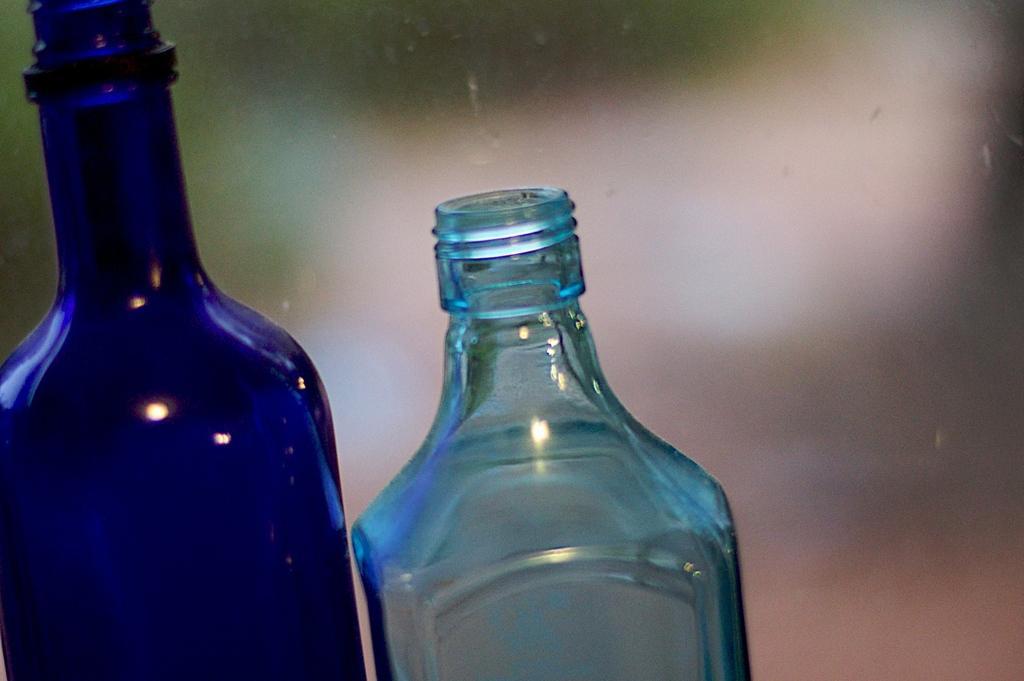Please provide a concise description of this image. This picture is mainly highlighted with two water bottles without caps. 